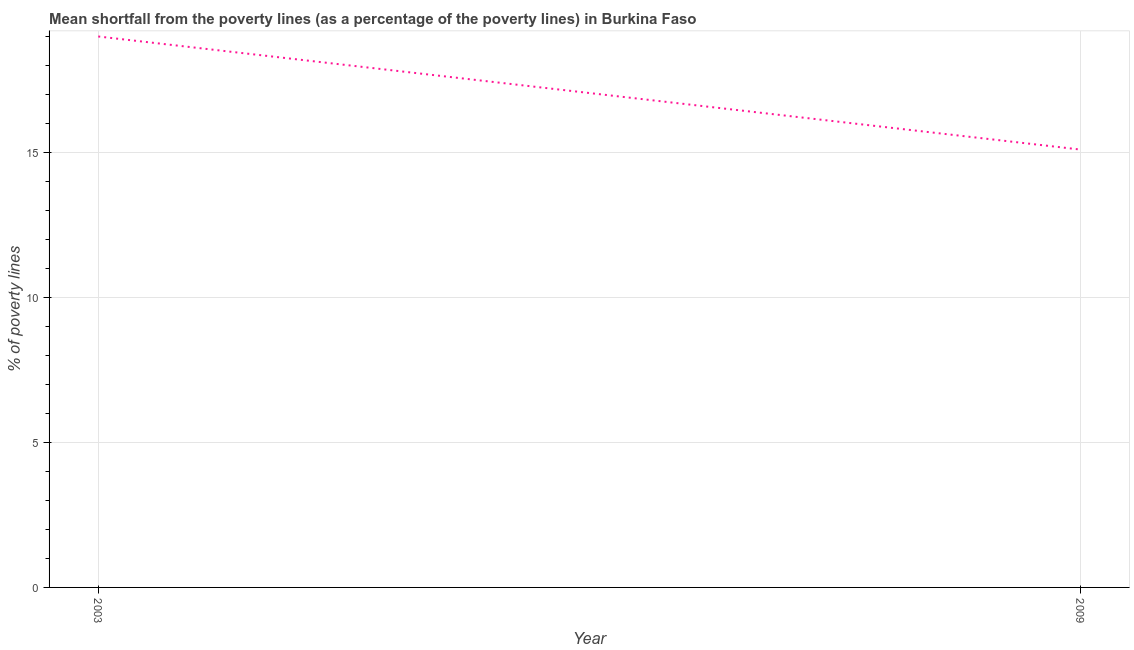Across all years, what is the maximum poverty gap at national poverty lines?
Give a very brief answer. 19. In which year was the poverty gap at national poverty lines maximum?
Give a very brief answer. 2003. What is the sum of the poverty gap at national poverty lines?
Keep it short and to the point. 34.1. What is the difference between the poverty gap at national poverty lines in 2003 and 2009?
Offer a terse response. 3.9. What is the average poverty gap at national poverty lines per year?
Your answer should be very brief. 17.05. What is the median poverty gap at national poverty lines?
Ensure brevity in your answer.  17.05. What is the ratio of the poverty gap at national poverty lines in 2003 to that in 2009?
Your answer should be very brief. 1.26. Is the poverty gap at national poverty lines in 2003 less than that in 2009?
Provide a short and direct response. No. In how many years, is the poverty gap at national poverty lines greater than the average poverty gap at national poverty lines taken over all years?
Provide a short and direct response. 1. Does the poverty gap at national poverty lines monotonically increase over the years?
Ensure brevity in your answer.  No. How many lines are there?
Provide a succinct answer. 1. How many years are there in the graph?
Give a very brief answer. 2. What is the difference between two consecutive major ticks on the Y-axis?
Make the answer very short. 5. Does the graph contain any zero values?
Offer a very short reply. No. Does the graph contain grids?
Provide a short and direct response. Yes. What is the title of the graph?
Give a very brief answer. Mean shortfall from the poverty lines (as a percentage of the poverty lines) in Burkina Faso. What is the label or title of the X-axis?
Give a very brief answer. Year. What is the label or title of the Y-axis?
Your answer should be very brief. % of poverty lines. What is the difference between the % of poverty lines in 2003 and 2009?
Provide a short and direct response. 3.9. What is the ratio of the % of poverty lines in 2003 to that in 2009?
Your response must be concise. 1.26. 